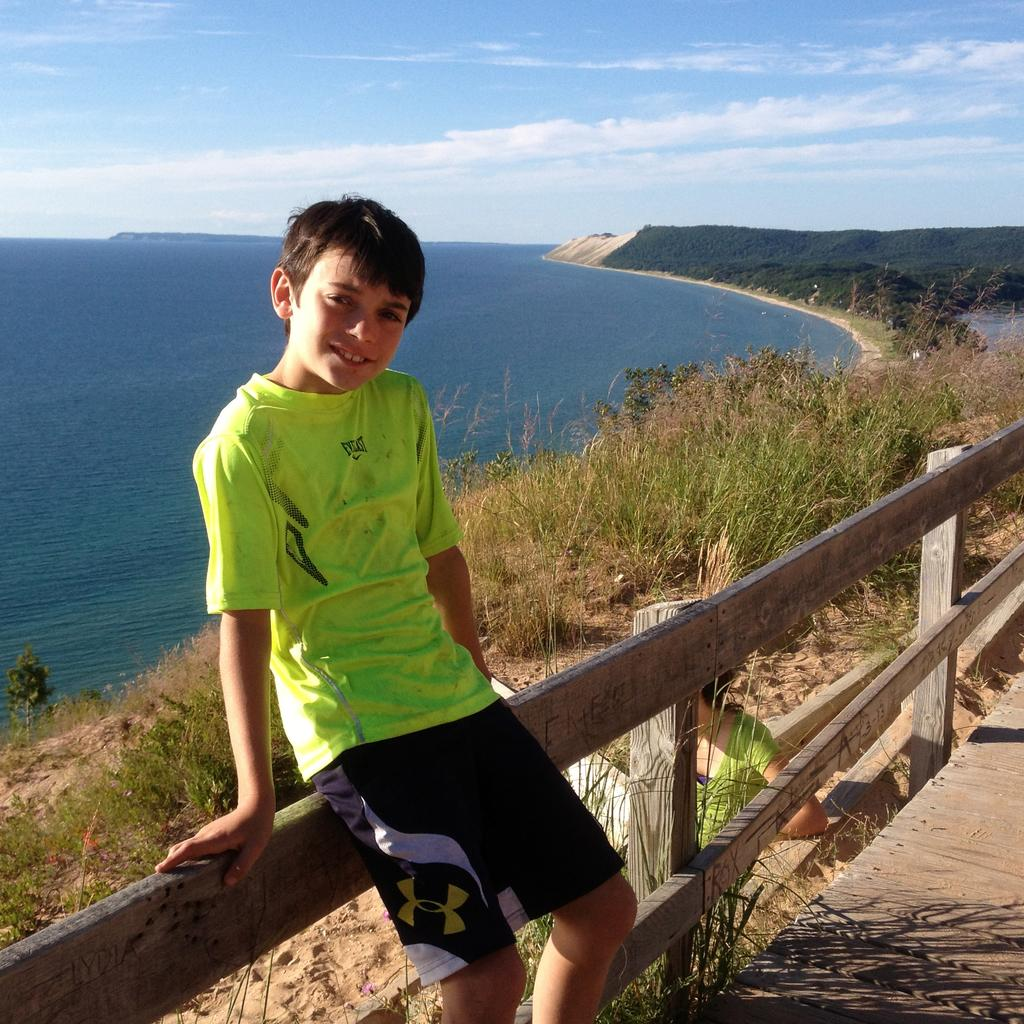Provide a one-sentence caption for the provided image. a boy sitting on a fence overlooking a body of water in an everlast shirt. 